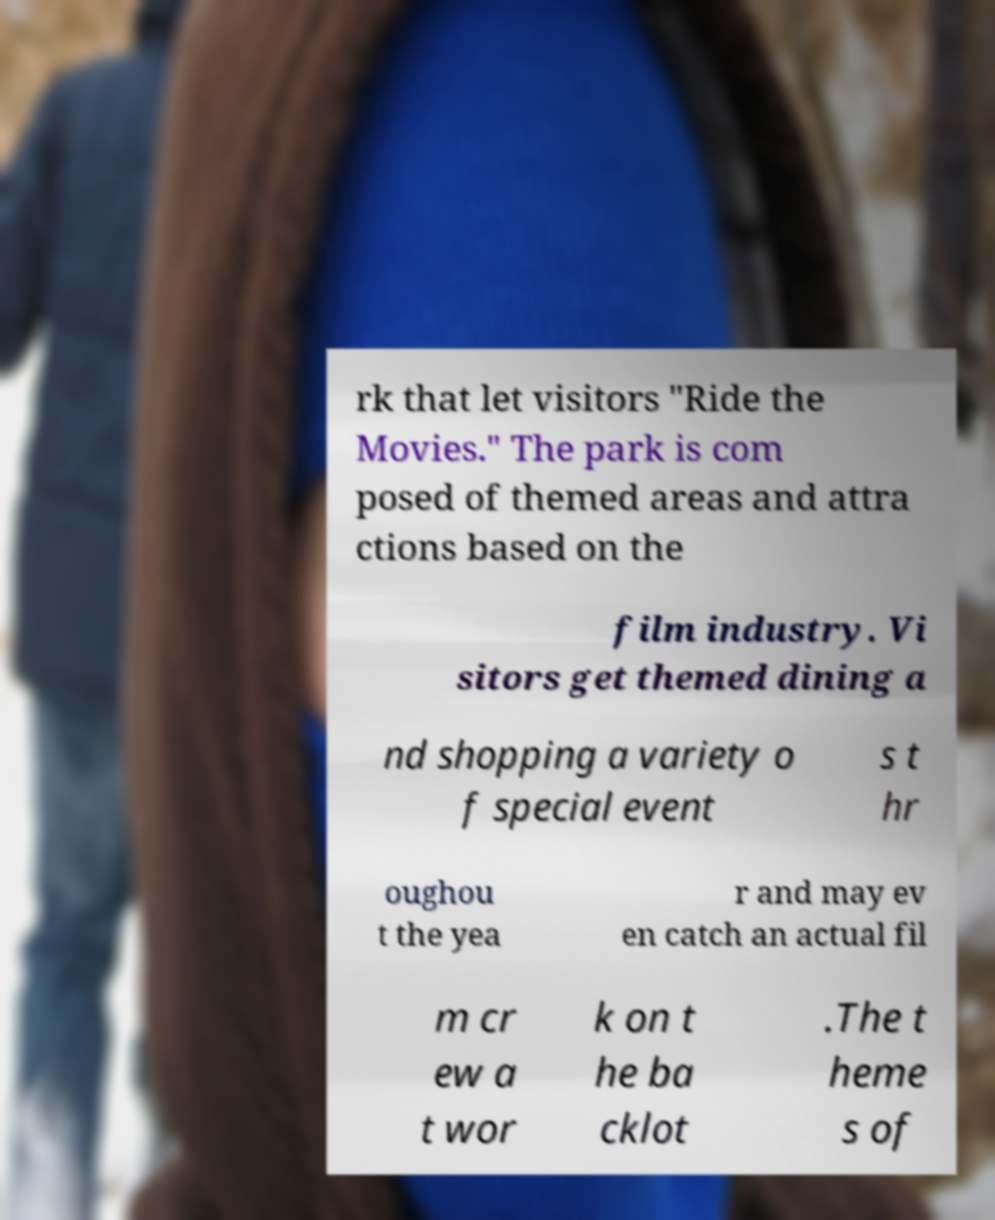Can you accurately transcribe the text from the provided image for me? rk that let visitors "Ride the Movies." The park is com posed of themed areas and attra ctions based on the film industry. Vi sitors get themed dining a nd shopping a variety o f special event s t hr oughou t the yea r and may ev en catch an actual fil m cr ew a t wor k on t he ba cklot .The t heme s of 